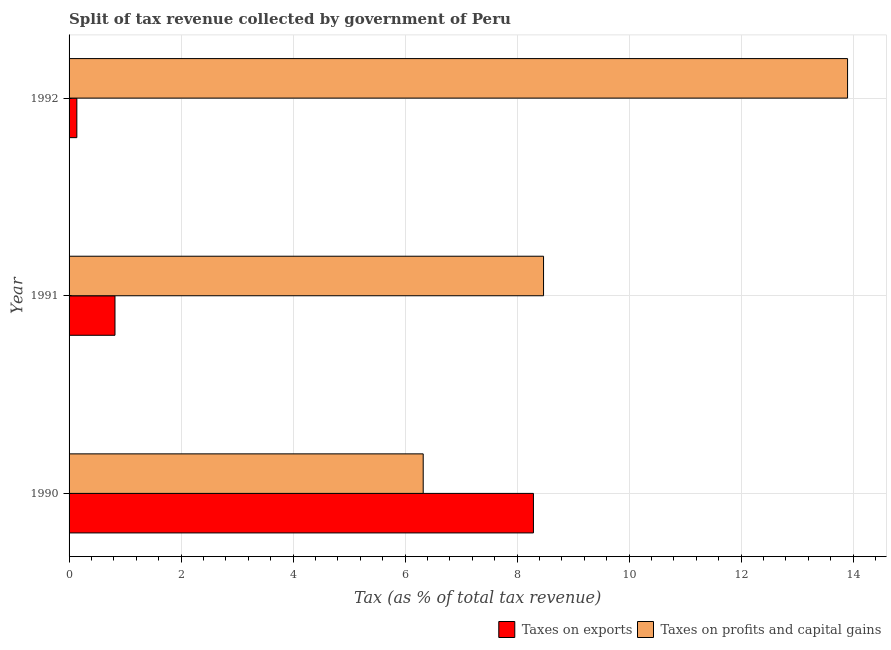How many bars are there on the 2nd tick from the bottom?
Your answer should be compact. 2. In how many cases, is the number of bars for a given year not equal to the number of legend labels?
Your answer should be compact. 0. What is the percentage of revenue obtained from taxes on profits and capital gains in 1990?
Your answer should be very brief. 6.32. Across all years, what is the maximum percentage of revenue obtained from taxes on exports?
Keep it short and to the point. 8.29. Across all years, what is the minimum percentage of revenue obtained from taxes on exports?
Offer a terse response. 0.14. In which year was the percentage of revenue obtained from taxes on exports maximum?
Your answer should be compact. 1990. In which year was the percentage of revenue obtained from taxes on exports minimum?
Ensure brevity in your answer.  1992. What is the total percentage of revenue obtained from taxes on profits and capital gains in the graph?
Your answer should be compact. 28.69. What is the difference between the percentage of revenue obtained from taxes on exports in 1990 and that in 1992?
Give a very brief answer. 8.15. What is the difference between the percentage of revenue obtained from taxes on profits and capital gains in 1990 and the percentage of revenue obtained from taxes on exports in 1991?
Your answer should be compact. 5.5. What is the average percentage of revenue obtained from taxes on exports per year?
Make the answer very short. 3.08. In the year 1990, what is the difference between the percentage of revenue obtained from taxes on exports and percentage of revenue obtained from taxes on profits and capital gains?
Your answer should be very brief. 1.97. In how many years, is the percentage of revenue obtained from taxes on profits and capital gains greater than 2.8 %?
Provide a succinct answer. 3. What is the ratio of the percentage of revenue obtained from taxes on profits and capital gains in 1991 to that in 1992?
Give a very brief answer. 0.61. What is the difference between the highest and the second highest percentage of revenue obtained from taxes on profits and capital gains?
Offer a terse response. 5.43. What is the difference between the highest and the lowest percentage of revenue obtained from taxes on profits and capital gains?
Offer a very short reply. 7.58. Is the sum of the percentage of revenue obtained from taxes on exports in 1991 and 1992 greater than the maximum percentage of revenue obtained from taxes on profits and capital gains across all years?
Give a very brief answer. No. What does the 2nd bar from the top in 1991 represents?
Offer a terse response. Taxes on exports. What does the 2nd bar from the bottom in 1992 represents?
Your answer should be very brief. Taxes on profits and capital gains. How many bars are there?
Ensure brevity in your answer.  6. How many years are there in the graph?
Give a very brief answer. 3. What is the difference between two consecutive major ticks on the X-axis?
Keep it short and to the point. 2. Does the graph contain grids?
Give a very brief answer. Yes. Where does the legend appear in the graph?
Your answer should be very brief. Bottom right. How are the legend labels stacked?
Your response must be concise. Horizontal. What is the title of the graph?
Make the answer very short. Split of tax revenue collected by government of Peru. Does "Taxes on profits and capital gains" appear as one of the legend labels in the graph?
Keep it short and to the point. Yes. What is the label or title of the X-axis?
Give a very brief answer. Tax (as % of total tax revenue). What is the Tax (as % of total tax revenue) in Taxes on exports in 1990?
Your answer should be compact. 8.29. What is the Tax (as % of total tax revenue) in Taxes on profits and capital gains in 1990?
Provide a short and direct response. 6.32. What is the Tax (as % of total tax revenue) in Taxes on exports in 1991?
Offer a very short reply. 0.82. What is the Tax (as % of total tax revenue) of Taxes on profits and capital gains in 1991?
Offer a very short reply. 8.47. What is the Tax (as % of total tax revenue) of Taxes on exports in 1992?
Offer a terse response. 0.14. What is the Tax (as % of total tax revenue) of Taxes on profits and capital gains in 1992?
Your response must be concise. 13.9. Across all years, what is the maximum Tax (as % of total tax revenue) in Taxes on exports?
Your response must be concise. 8.29. Across all years, what is the maximum Tax (as % of total tax revenue) in Taxes on profits and capital gains?
Your answer should be compact. 13.9. Across all years, what is the minimum Tax (as % of total tax revenue) in Taxes on exports?
Offer a terse response. 0.14. Across all years, what is the minimum Tax (as % of total tax revenue) of Taxes on profits and capital gains?
Make the answer very short. 6.32. What is the total Tax (as % of total tax revenue) of Taxes on exports in the graph?
Your answer should be compact. 9.25. What is the total Tax (as % of total tax revenue) in Taxes on profits and capital gains in the graph?
Keep it short and to the point. 28.7. What is the difference between the Tax (as % of total tax revenue) in Taxes on exports in 1990 and that in 1991?
Your answer should be compact. 7.47. What is the difference between the Tax (as % of total tax revenue) in Taxes on profits and capital gains in 1990 and that in 1991?
Give a very brief answer. -2.15. What is the difference between the Tax (as % of total tax revenue) in Taxes on exports in 1990 and that in 1992?
Offer a terse response. 8.15. What is the difference between the Tax (as % of total tax revenue) in Taxes on profits and capital gains in 1990 and that in 1992?
Your answer should be very brief. -7.58. What is the difference between the Tax (as % of total tax revenue) in Taxes on exports in 1991 and that in 1992?
Ensure brevity in your answer.  0.68. What is the difference between the Tax (as % of total tax revenue) in Taxes on profits and capital gains in 1991 and that in 1992?
Your response must be concise. -5.43. What is the difference between the Tax (as % of total tax revenue) in Taxes on exports in 1990 and the Tax (as % of total tax revenue) in Taxes on profits and capital gains in 1991?
Give a very brief answer. -0.18. What is the difference between the Tax (as % of total tax revenue) of Taxes on exports in 1990 and the Tax (as % of total tax revenue) of Taxes on profits and capital gains in 1992?
Make the answer very short. -5.61. What is the difference between the Tax (as % of total tax revenue) of Taxes on exports in 1991 and the Tax (as % of total tax revenue) of Taxes on profits and capital gains in 1992?
Provide a succinct answer. -13.08. What is the average Tax (as % of total tax revenue) of Taxes on exports per year?
Your answer should be compact. 3.08. What is the average Tax (as % of total tax revenue) in Taxes on profits and capital gains per year?
Make the answer very short. 9.56. In the year 1990, what is the difference between the Tax (as % of total tax revenue) in Taxes on exports and Tax (as % of total tax revenue) in Taxes on profits and capital gains?
Provide a succinct answer. 1.97. In the year 1991, what is the difference between the Tax (as % of total tax revenue) of Taxes on exports and Tax (as % of total tax revenue) of Taxes on profits and capital gains?
Make the answer very short. -7.65. In the year 1992, what is the difference between the Tax (as % of total tax revenue) of Taxes on exports and Tax (as % of total tax revenue) of Taxes on profits and capital gains?
Keep it short and to the point. -13.76. What is the ratio of the Tax (as % of total tax revenue) of Taxes on exports in 1990 to that in 1991?
Your answer should be compact. 10.11. What is the ratio of the Tax (as % of total tax revenue) in Taxes on profits and capital gains in 1990 to that in 1991?
Make the answer very short. 0.75. What is the ratio of the Tax (as % of total tax revenue) of Taxes on exports in 1990 to that in 1992?
Provide a short and direct response. 59.74. What is the ratio of the Tax (as % of total tax revenue) of Taxes on profits and capital gains in 1990 to that in 1992?
Provide a succinct answer. 0.45. What is the ratio of the Tax (as % of total tax revenue) in Taxes on exports in 1991 to that in 1992?
Offer a terse response. 5.91. What is the ratio of the Tax (as % of total tax revenue) of Taxes on profits and capital gains in 1991 to that in 1992?
Provide a succinct answer. 0.61. What is the difference between the highest and the second highest Tax (as % of total tax revenue) of Taxes on exports?
Your answer should be compact. 7.47. What is the difference between the highest and the second highest Tax (as % of total tax revenue) in Taxes on profits and capital gains?
Your response must be concise. 5.43. What is the difference between the highest and the lowest Tax (as % of total tax revenue) of Taxes on exports?
Provide a succinct answer. 8.15. What is the difference between the highest and the lowest Tax (as % of total tax revenue) of Taxes on profits and capital gains?
Your answer should be very brief. 7.58. 